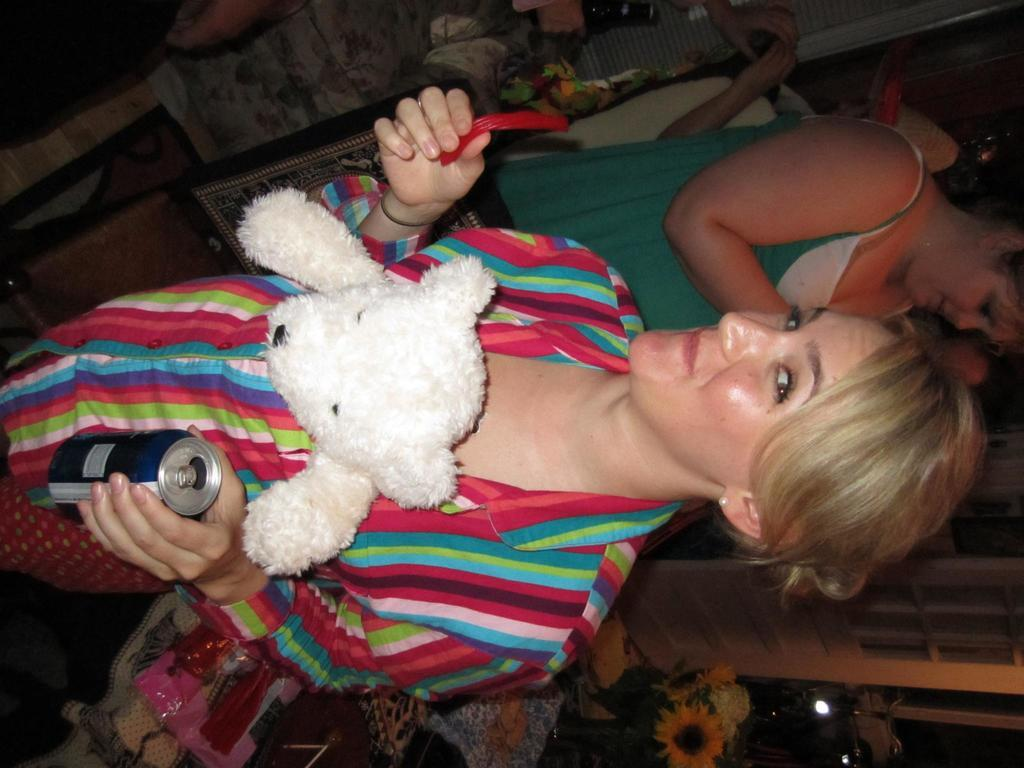How many people are present in the image? There are people in the image, but the exact number is not specified. What is one person doing in the image? One person is holding objects in the image. What type of toy can be seen in the image? There is a teddy bear in the image. What type of decorative item is present in the image? There is a flower vase in the image. What mode of transportation is visible in the image? There is a bicycle in the image. Can you describe any other objects present in the image? There are some other unspecified objects in the image. What type of stage can be seen in the image? There is no stage present in the image. What type of trail is visible in the image? There is no trail visible in the image. 